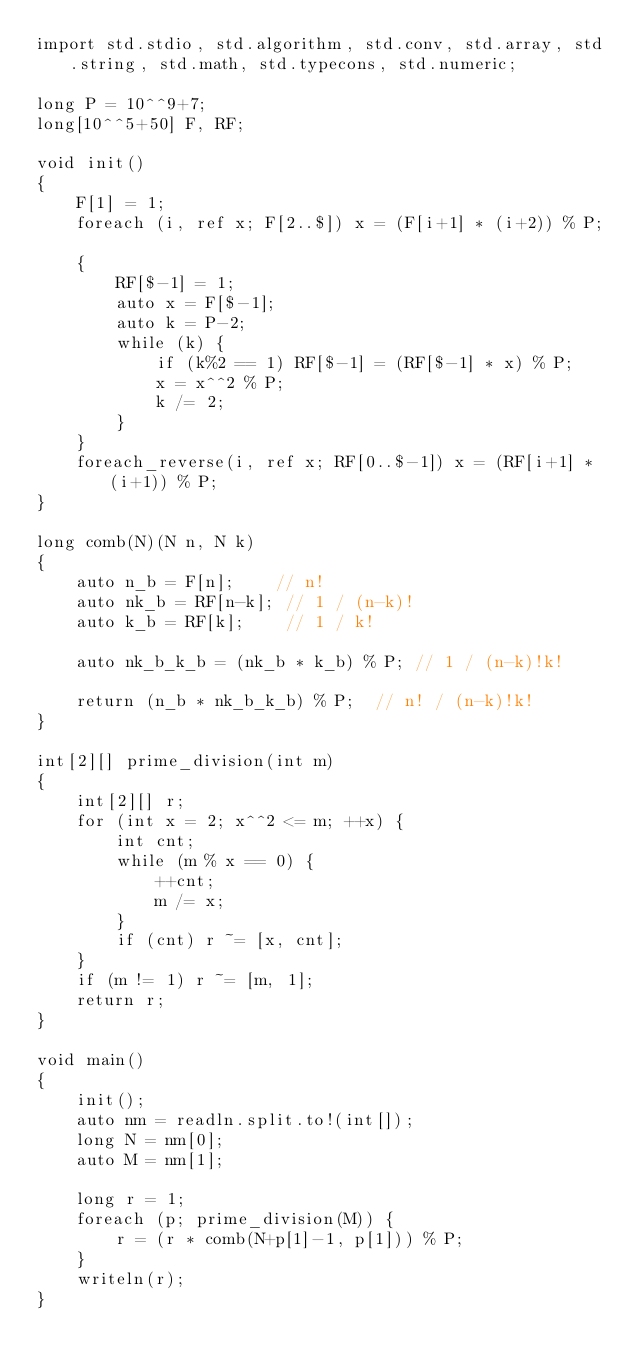Convert code to text. <code><loc_0><loc_0><loc_500><loc_500><_D_>import std.stdio, std.algorithm, std.conv, std.array, std.string, std.math, std.typecons, std.numeric;

long P = 10^^9+7;
long[10^^5+50] F, RF;

void init()
{
    F[1] = 1;
    foreach (i, ref x; F[2..$]) x = (F[i+1] * (i+2)) % P;

    {
        RF[$-1] = 1;
        auto x = F[$-1];
        auto k = P-2;
        while (k) {
            if (k%2 == 1) RF[$-1] = (RF[$-1] * x) % P;
            x = x^^2 % P;
            k /= 2;
        }
    }
    foreach_reverse(i, ref x; RF[0..$-1]) x = (RF[i+1] * (i+1)) % P;
}

long comb(N)(N n, N k)
{
    auto n_b = F[n];    // n!
    auto nk_b = RF[n-k]; // 1 / (n-k)!
    auto k_b = RF[k];    // 1 / k!

    auto nk_b_k_b = (nk_b * k_b) % P; // 1 / (n-k)!k!

    return (n_b * nk_b_k_b) % P;  // n! / (n-k)!k!
}

int[2][] prime_division(int m)
{
    int[2][] r;
    for (int x = 2; x^^2 <= m; ++x) {
        int cnt;
        while (m % x == 0) {
            ++cnt;
            m /= x;
        }
        if (cnt) r ~= [x, cnt];
    }
    if (m != 1) r ~= [m, 1];
    return r;
}

void main()
{
    init();
    auto nm = readln.split.to!(int[]);
    long N = nm[0];
    auto M = nm[1];

    long r = 1;
    foreach (p; prime_division(M)) {
        r = (r * comb(N+p[1]-1, p[1])) % P;
    }
    writeln(r);
}</code> 